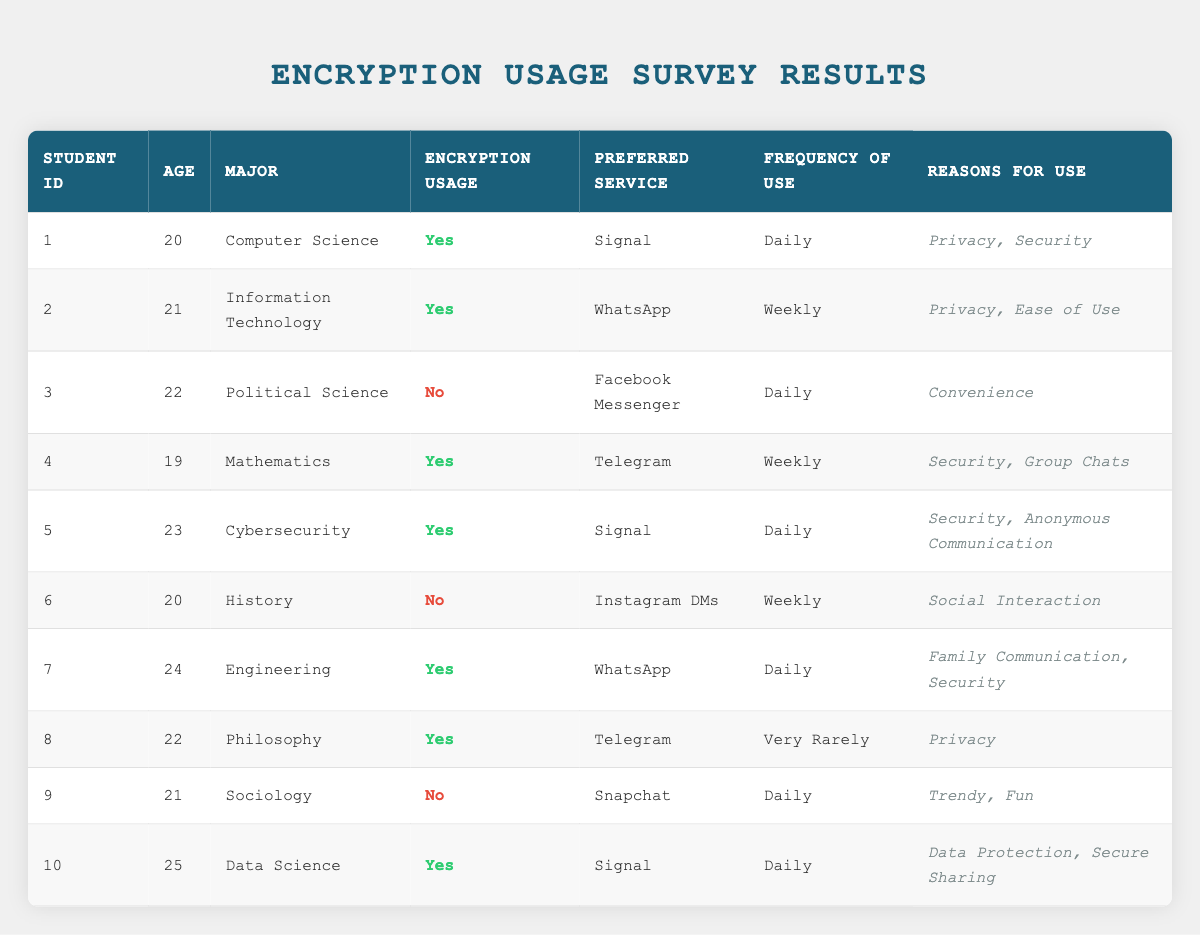What is the most preferred encryption service among students in the survey? To find the most preferred encryption service, we look at the "Preferred Service" column. The services listed are Signal, WhatsApp, Telegram, and Facebook Messenger. Signal appears 4 times, WhatsApp appears 3 times, and Telegram appears 2 times, while Facebook Messenger and Snapchat appear once for students who do not use encryption. Therefore, Signal is the most preferred service.
Answer: Signal How many students use encryption daily? We can count the number of students who have the "Frequency of Use" listed as "Daily" and have "Encryption Usage" marked as true. Looking at the table, there are 4 students (IDs 1, 5, 7, and 10) who use encryption daily.
Answer: 4 Is there a student majoring in History who uses encryption? By scanning the rows, we see that the student majoring in History (student ID 6) has "Encryption Usage" marked as false. Therefore, this student does not use encryption.
Answer: No What are the reasons for using encryption among all students who use it? We look for students with "Encryption Usage" marked as true and list their reasons. The reasons include Privacy, Security, Ease of Use, Group Chats, Anonymous Communication, Family Communication, and Data Protection. The complete reasons when combined and filtered for duplicates are Privacy, Security, Ease of Use, Group Chats, Anonymous Communication, Family Communication, and Data Protection.
Answer: Privacy, Security, Ease of Use, Group Chats, Anonymous Communication, Family Communication, Data Protection What is the average age of students who do not use encryption? We identify students with "Encryption Usage" marked as false, which are student IDs 3, 6, and 9. Their ages are 22, 20, and 21, respectively. Summing these ages gives 22 + 20 + 21 = 63. There are 3 students, so the average age is 63/3 = 21.
Answer: 21 How many students major in Computer Science and use encryption? We need to find students who are majoring in Computer Science and have "Encryption Usage" marked as true. From the table, only student ID 1 meets this criterion. Therefore, there is 1 student in that major who uses encryption.
Answer: 1 Which encryption service is used weekly by students? Looking at the "Frequency of Use" and "Preferred Service" columns, students using encryption with a frequency of "Weekly" prefer Signal and Telegram. Specifically, students 2 (WhatsApp) and 4 (Telegram) use encryption weekly, while student 5 (Signal) uses it daily. Thus, the encryption services used weekly are WhatsApp and Telegram.
Answer: WhatsApp, Telegram Is there any student in the survey who uses Snapchat and also uses encryption? We check the entry for Snapchat in the table. The student with ID 9 lists Snapchat as their preferred service, but "Encryption Usage" is marked as false. Therefore, this student does not use encryption.
Answer: No 